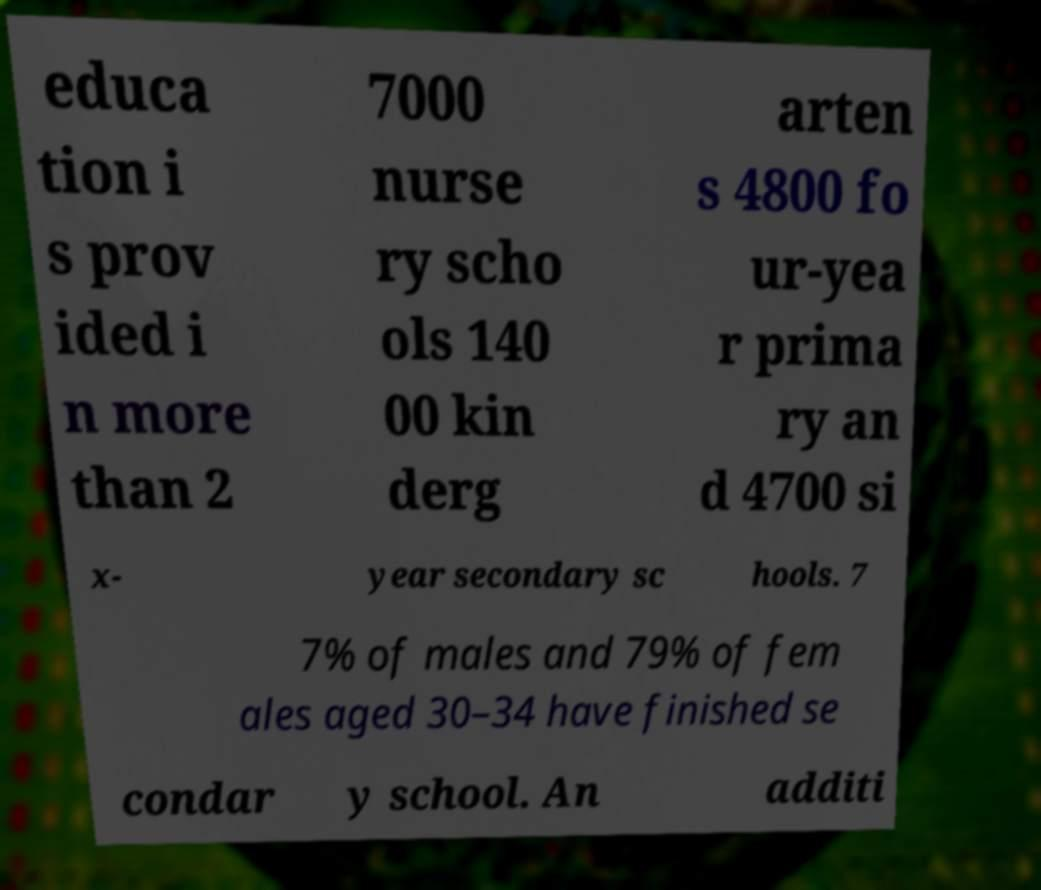Could you extract and type out the text from this image? educa tion i s prov ided i n more than 2 7000 nurse ry scho ols 140 00 kin derg arten s 4800 fo ur-yea r prima ry an d 4700 si x- year secondary sc hools. 7 7% of males and 79% of fem ales aged 30–34 have finished se condar y school. An additi 